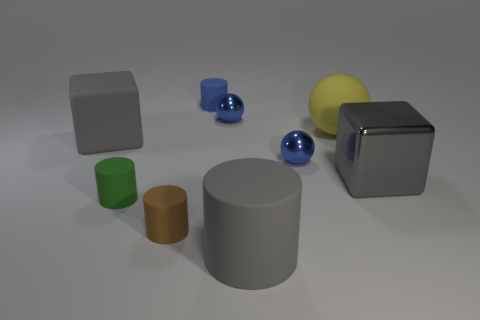What can you say about the texture and material of the objects? The objects in the image have a matte finish with little to no specular highlights, making it difficult to ascertain their exact materials. However, the lack of strong reflections suggests they might be made of a non-reflective material like plastic or unpolished metal. The cylinder and cube that appear gray might imply a metallic quality, but this is speculative. 